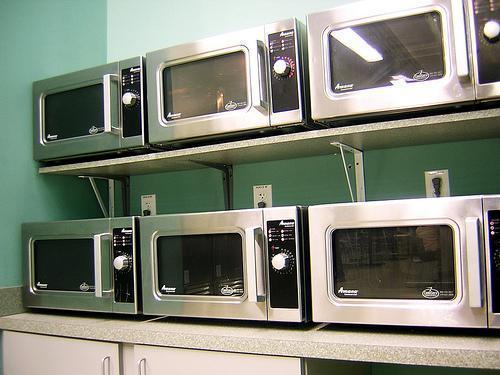How many microwaves are there?
Give a very brief answer. 6. 